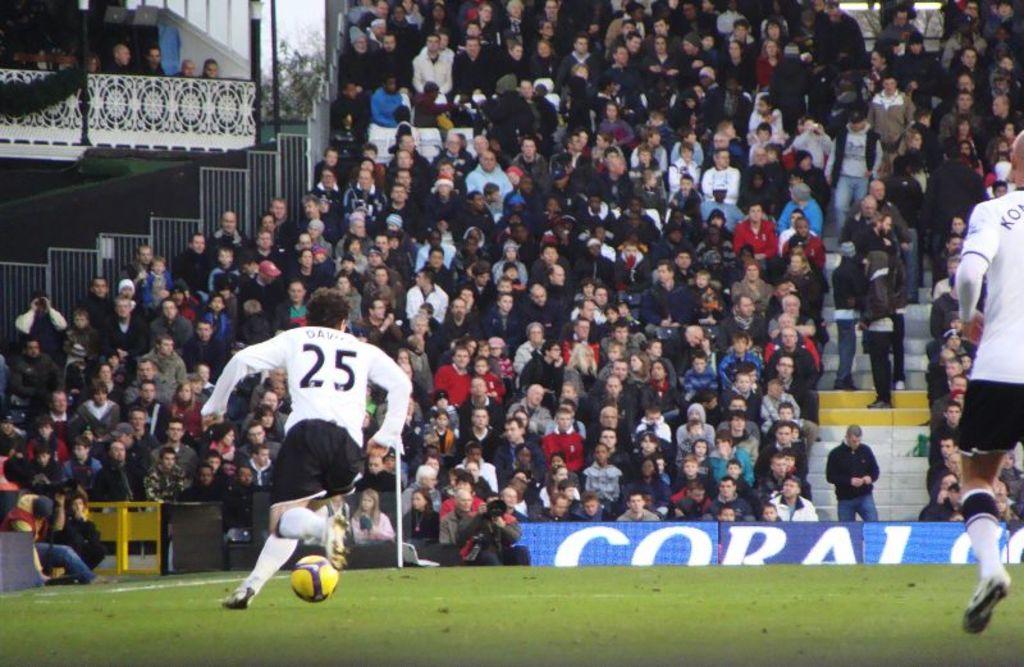What is the jersey number of the athlete who has control of the ball?
Keep it short and to the point. 25. What word is written in white?
Provide a short and direct response. Coral. 